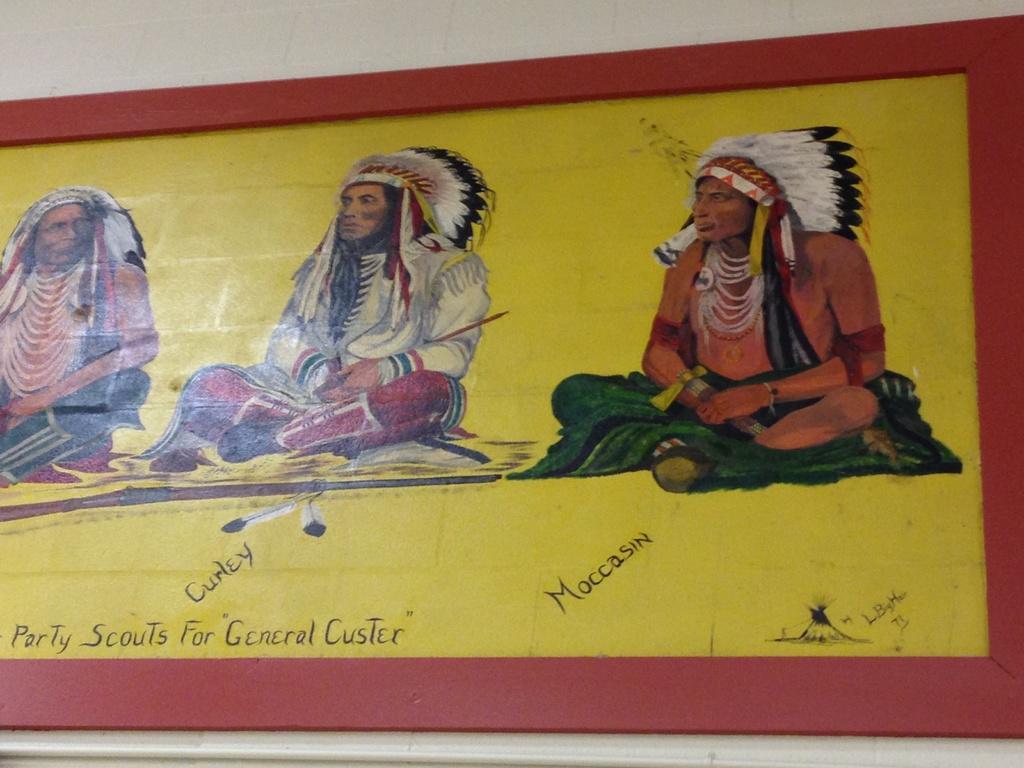Please provide a concise description of this image. There is a poster having a painting on which, there are three persons sitting and there are texts. And the background is white in color. 